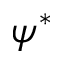Convert formula to latex. <formula><loc_0><loc_0><loc_500><loc_500>\psi ^ { * }</formula> 